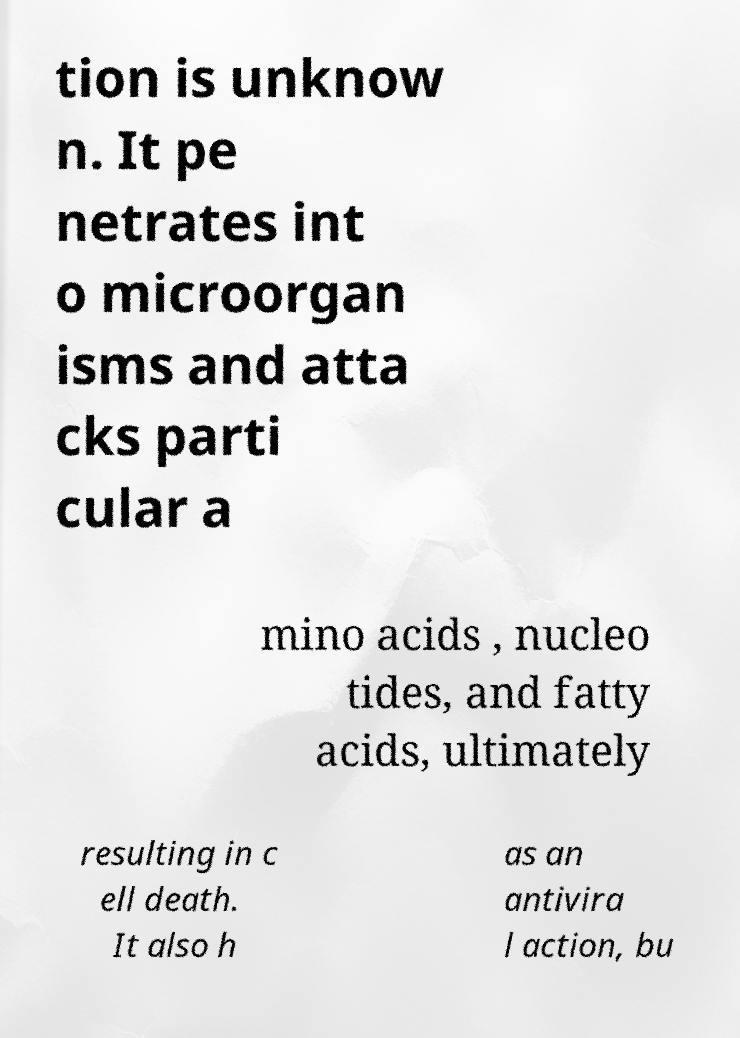I need the written content from this picture converted into text. Can you do that? tion is unknow n. It pe netrates int o microorgan isms and atta cks parti cular a mino acids , nucleo tides, and fatty acids, ultimately resulting in c ell death. It also h as an antivira l action, bu 